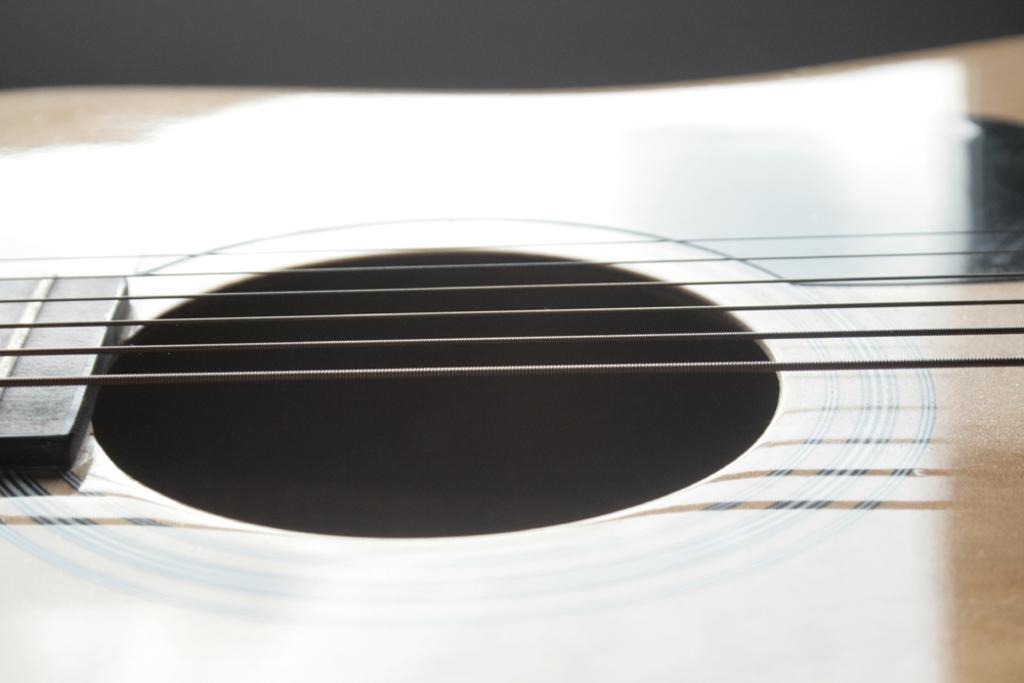What musical instrument is featured in the image? The strings of a guitar are visible in the image. Can you describe the specific part of the guitar that is shown? The strings of the guitar are visible in the image. How many women are playing the guitar in the image? There are no women present in the image; it only features the strings of a guitar. What type of spade is being used to dig near the guitar in the image? There is no spade or digging activity present in the image; it only features the strings of a guitar. 